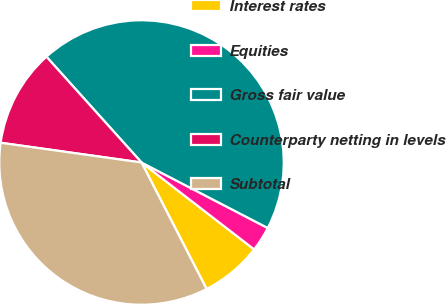<chart> <loc_0><loc_0><loc_500><loc_500><pie_chart><fcel>Interest rates<fcel>Equities<fcel>Gross fair value<fcel>Counterparty netting in levels<fcel>Subtotal<nl><fcel>6.98%<fcel>2.84%<fcel>44.27%<fcel>11.13%<fcel>34.78%<nl></chart> 